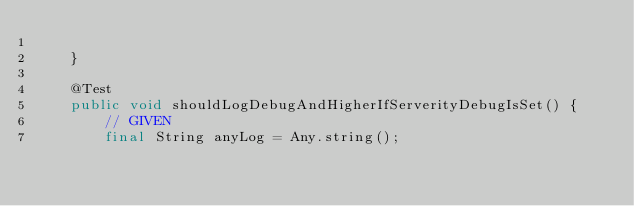<code> <loc_0><loc_0><loc_500><loc_500><_Java_>
    }

    @Test
    public void shouldLogDebugAndHigherIfServerityDebugIsSet() {
        // GIVEN
        final String anyLog = Any.string();</code> 